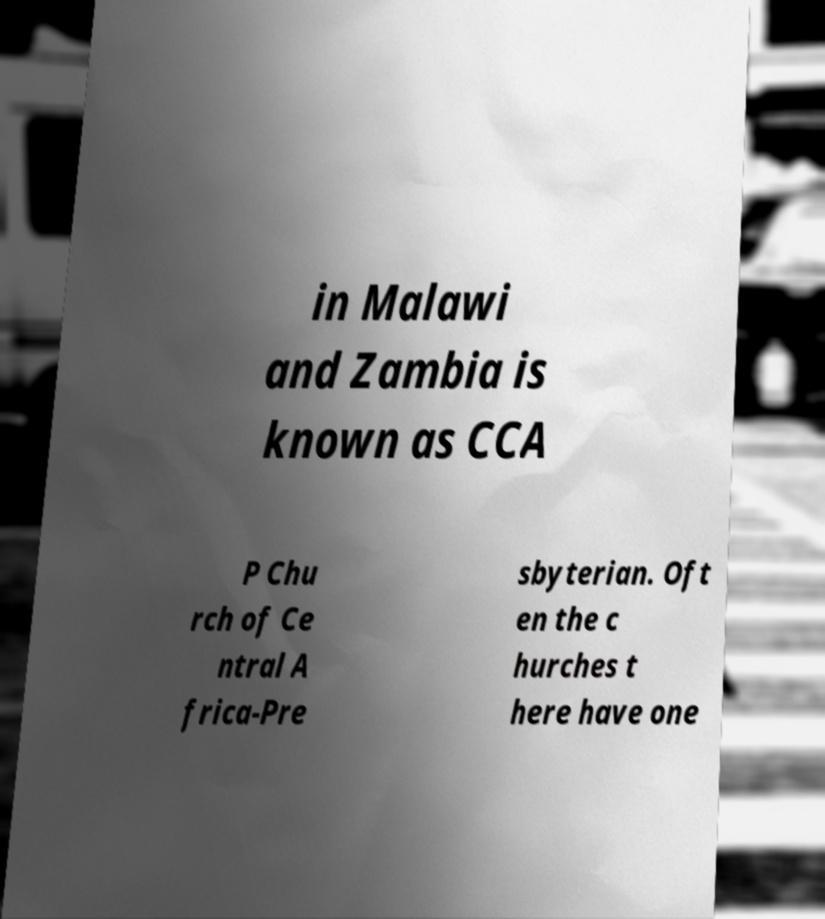Can you read and provide the text displayed in the image?This photo seems to have some interesting text. Can you extract and type it out for me? in Malawi and Zambia is known as CCA P Chu rch of Ce ntral A frica-Pre sbyterian. Oft en the c hurches t here have one 